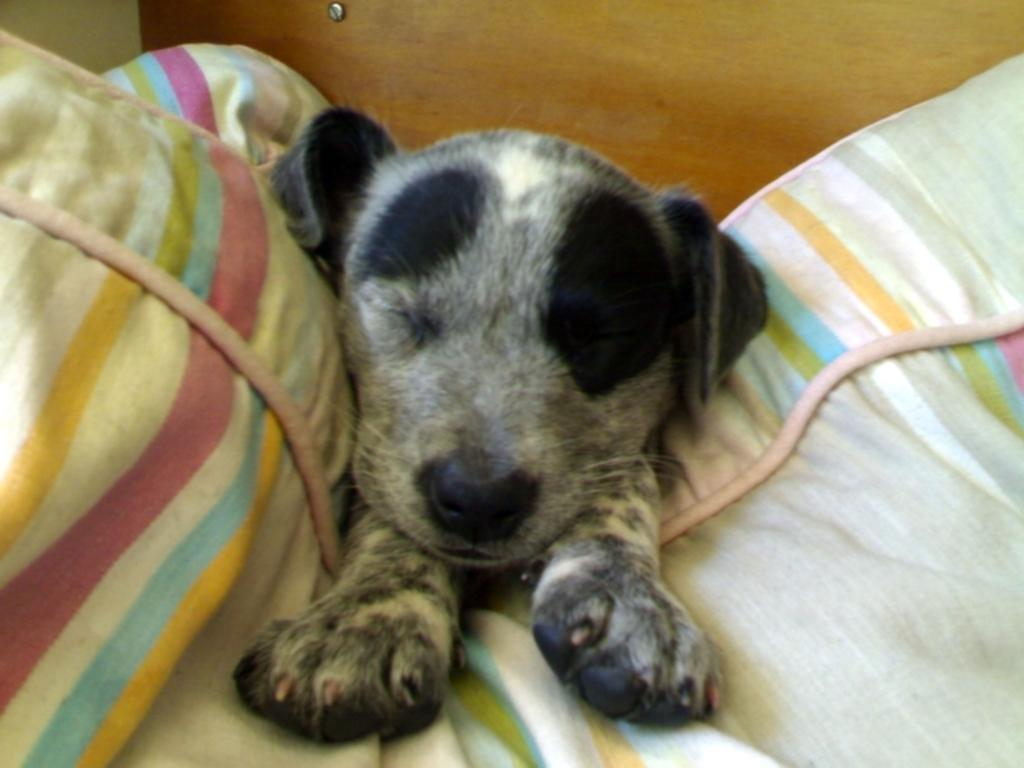What type of animal can be seen in the image? There is a dog in the image. What is the dog doing in the image? The dog is sleeping. What is the dog resting on in the image? The dog is on a cloth. What can be seen in the background of the image? There is a wooden object in the background of the image. What is the color of the background in the image? The background of the image is cream-colored. What type of toothbrush is the dog using in the image? There is no toothbrush present in the image, and the dog is sleeping, not using any object. 